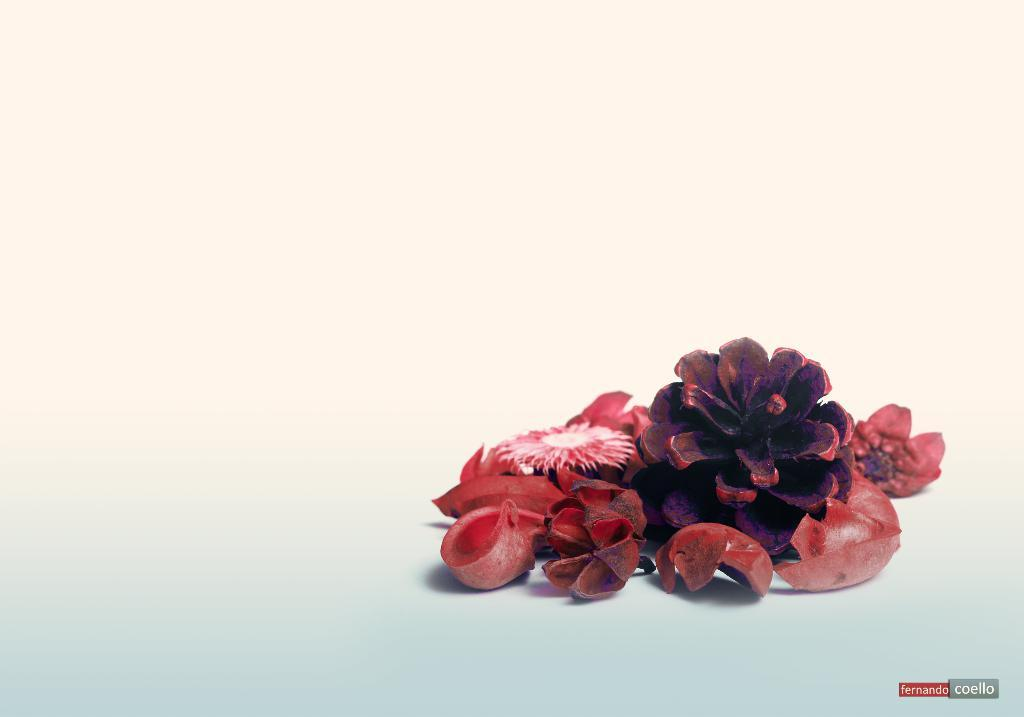What type of plants can be seen in the image? There are flowers in the image. What part of the flowers can be found on the floor in the image? There are petals on the floor in the image. What type of army is depicted on the canvas in the image? There is no canvas or army present in the image; it features flowers and petals on the floor. How many wings can be seen on the flowers in the image? Flowers do not have wings, so this question cannot be answered based on the information given. 